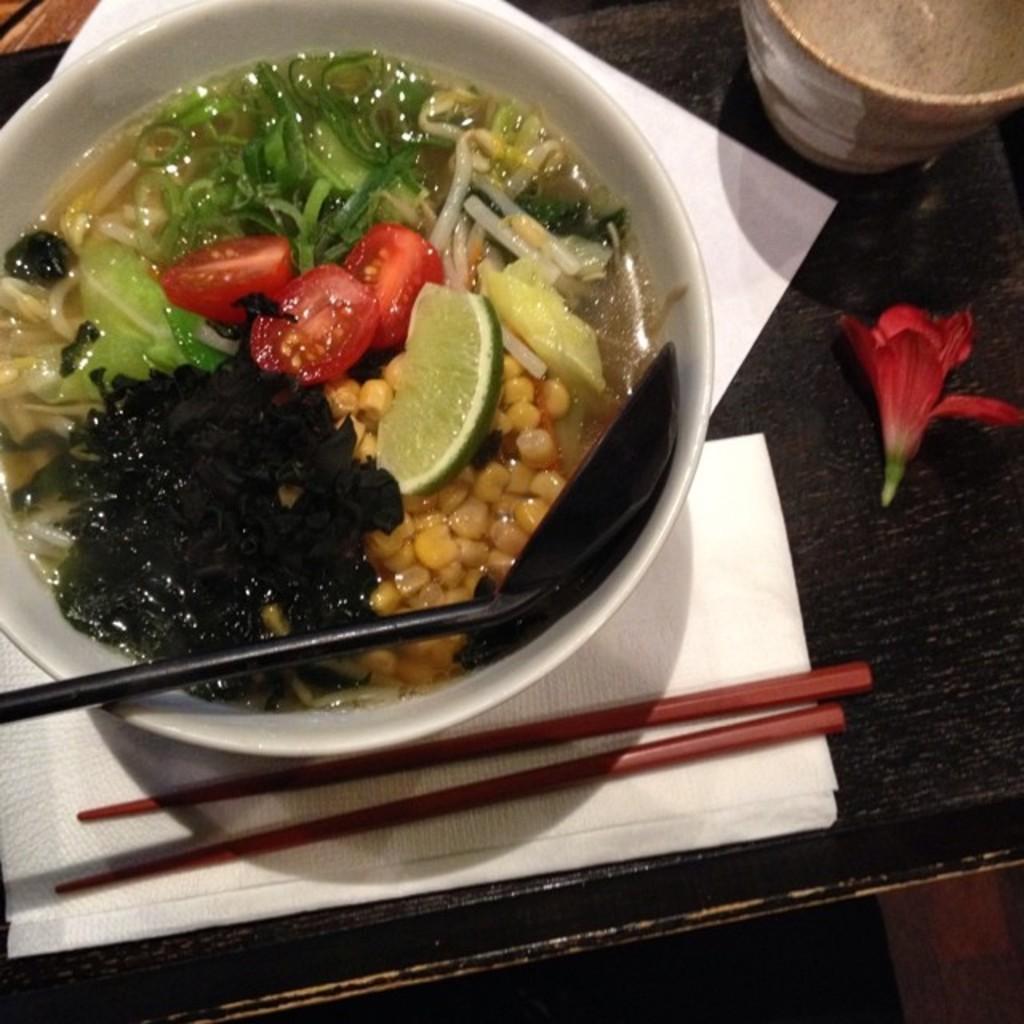Please provide a concise description of this image. In the image there is a table. On table we can see a bowl with some food,tissue,chopstick,flower,glass with some drink and a cloth which is in black color. 